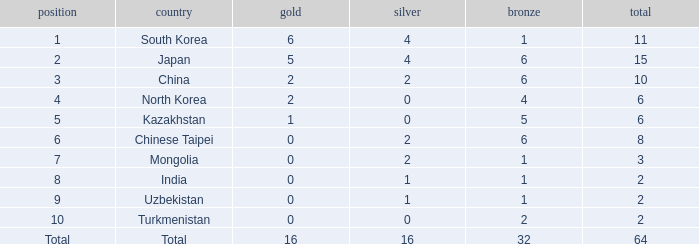What's the biggest Bronze that has less than 0 Silvers? None. 